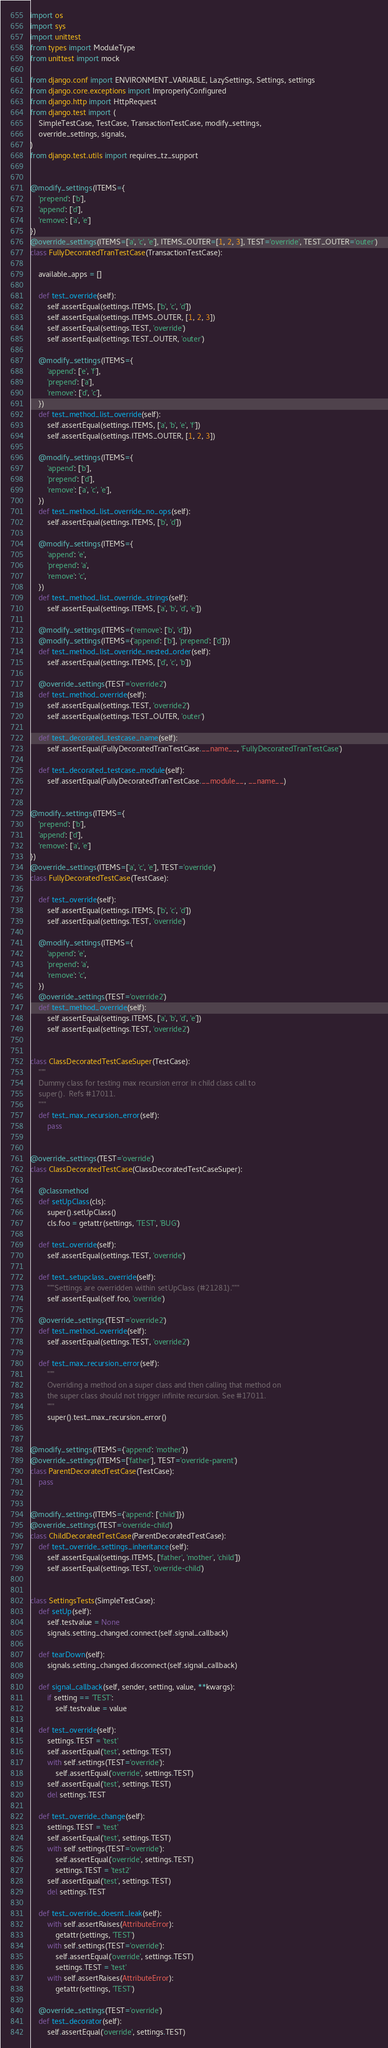Convert code to text. <code><loc_0><loc_0><loc_500><loc_500><_Python_>import os
import sys
import unittest
from types import ModuleType
from unittest import mock

from django.conf import ENVIRONMENT_VARIABLE, LazySettings, Settings, settings
from django.core.exceptions import ImproperlyConfigured
from django.http import HttpRequest
from django.test import (
    SimpleTestCase, TestCase, TransactionTestCase, modify_settings,
    override_settings, signals,
)
from django.test.utils import requires_tz_support


@modify_settings(ITEMS={
    'prepend': ['b'],
    'append': ['d'],
    'remove': ['a', 'e']
})
@override_settings(ITEMS=['a', 'c', 'e'], ITEMS_OUTER=[1, 2, 3], TEST='override', TEST_OUTER='outer')
class FullyDecoratedTranTestCase(TransactionTestCase):

    available_apps = []

    def test_override(self):
        self.assertEqual(settings.ITEMS, ['b', 'c', 'd'])
        self.assertEqual(settings.ITEMS_OUTER, [1, 2, 3])
        self.assertEqual(settings.TEST, 'override')
        self.assertEqual(settings.TEST_OUTER, 'outer')

    @modify_settings(ITEMS={
        'append': ['e', 'f'],
        'prepend': ['a'],
        'remove': ['d', 'c'],
    })
    def test_method_list_override(self):
        self.assertEqual(settings.ITEMS, ['a', 'b', 'e', 'f'])
        self.assertEqual(settings.ITEMS_OUTER, [1, 2, 3])

    @modify_settings(ITEMS={
        'append': ['b'],
        'prepend': ['d'],
        'remove': ['a', 'c', 'e'],
    })
    def test_method_list_override_no_ops(self):
        self.assertEqual(settings.ITEMS, ['b', 'd'])

    @modify_settings(ITEMS={
        'append': 'e',
        'prepend': 'a',
        'remove': 'c',
    })
    def test_method_list_override_strings(self):
        self.assertEqual(settings.ITEMS, ['a', 'b', 'd', 'e'])

    @modify_settings(ITEMS={'remove': ['b', 'd']})
    @modify_settings(ITEMS={'append': ['b'], 'prepend': ['d']})
    def test_method_list_override_nested_order(self):
        self.assertEqual(settings.ITEMS, ['d', 'c', 'b'])

    @override_settings(TEST='override2')
    def test_method_override(self):
        self.assertEqual(settings.TEST, 'override2')
        self.assertEqual(settings.TEST_OUTER, 'outer')

    def test_decorated_testcase_name(self):
        self.assertEqual(FullyDecoratedTranTestCase.__name__, 'FullyDecoratedTranTestCase')

    def test_decorated_testcase_module(self):
        self.assertEqual(FullyDecoratedTranTestCase.__module__, __name__)


@modify_settings(ITEMS={
    'prepend': ['b'],
    'append': ['d'],
    'remove': ['a', 'e']
})
@override_settings(ITEMS=['a', 'c', 'e'], TEST='override')
class FullyDecoratedTestCase(TestCase):

    def test_override(self):
        self.assertEqual(settings.ITEMS, ['b', 'c', 'd'])
        self.assertEqual(settings.TEST, 'override')

    @modify_settings(ITEMS={
        'append': 'e',
        'prepend': 'a',
        'remove': 'c',
    })
    @override_settings(TEST='override2')
    def test_method_override(self):
        self.assertEqual(settings.ITEMS, ['a', 'b', 'd', 'e'])
        self.assertEqual(settings.TEST, 'override2')


class ClassDecoratedTestCaseSuper(TestCase):
    """
    Dummy class for testing max recursion error in child class call to
    super().  Refs #17011.
    """
    def test_max_recursion_error(self):
        pass


@override_settings(TEST='override')
class ClassDecoratedTestCase(ClassDecoratedTestCaseSuper):

    @classmethod
    def setUpClass(cls):
        super().setUpClass()
        cls.foo = getattr(settings, 'TEST', 'BUG')

    def test_override(self):
        self.assertEqual(settings.TEST, 'override')

    def test_setupclass_override(self):
        """Settings are overridden within setUpClass (#21281)."""
        self.assertEqual(self.foo, 'override')

    @override_settings(TEST='override2')
    def test_method_override(self):
        self.assertEqual(settings.TEST, 'override2')

    def test_max_recursion_error(self):
        """
        Overriding a method on a super class and then calling that method on
        the super class should not trigger infinite recursion. See #17011.
        """
        super().test_max_recursion_error()


@modify_settings(ITEMS={'append': 'mother'})
@override_settings(ITEMS=['father'], TEST='override-parent')
class ParentDecoratedTestCase(TestCase):
    pass


@modify_settings(ITEMS={'append': ['child']})
@override_settings(TEST='override-child')
class ChildDecoratedTestCase(ParentDecoratedTestCase):
    def test_override_settings_inheritance(self):
        self.assertEqual(settings.ITEMS, ['father', 'mother', 'child'])
        self.assertEqual(settings.TEST, 'override-child')


class SettingsTests(SimpleTestCase):
    def setUp(self):
        self.testvalue = None
        signals.setting_changed.connect(self.signal_callback)

    def tearDown(self):
        signals.setting_changed.disconnect(self.signal_callback)

    def signal_callback(self, sender, setting, value, **kwargs):
        if setting == 'TEST':
            self.testvalue = value

    def test_override(self):
        settings.TEST = 'test'
        self.assertEqual('test', settings.TEST)
        with self.settings(TEST='override'):
            self.assertEqual('override', settings.TEST)
        self.assertEqual('test', settings.TEST)
        del settings.TEST

    def test_override_change(self):
        settings.TEST = 'test'
        self.assertEqual('test', settings.TEST)
        with self.settings(TEST='override'):
            self.assertEqual('override', settings.TEST)
            settings.TEST = 'test2'
        self.assertEqual('test', settings.TEST)
        del settings.TEST

    def test_override_doesnt_leak(self):
        with self.assertRaises(AttributeError):
            getattr(settings, 'TEST')
        with self.settings(TEST='override'):
            self.assertEqual('override', settings.TEST)
            settings.TEST = 'test'
        with self.assertRaises(AttributeError):
            getattr(settings, 'TEST')

    @override_settings(TEST='override')
    def test_decorator(self):
        self.assertEqual('override', settings.TEST)
</code> 